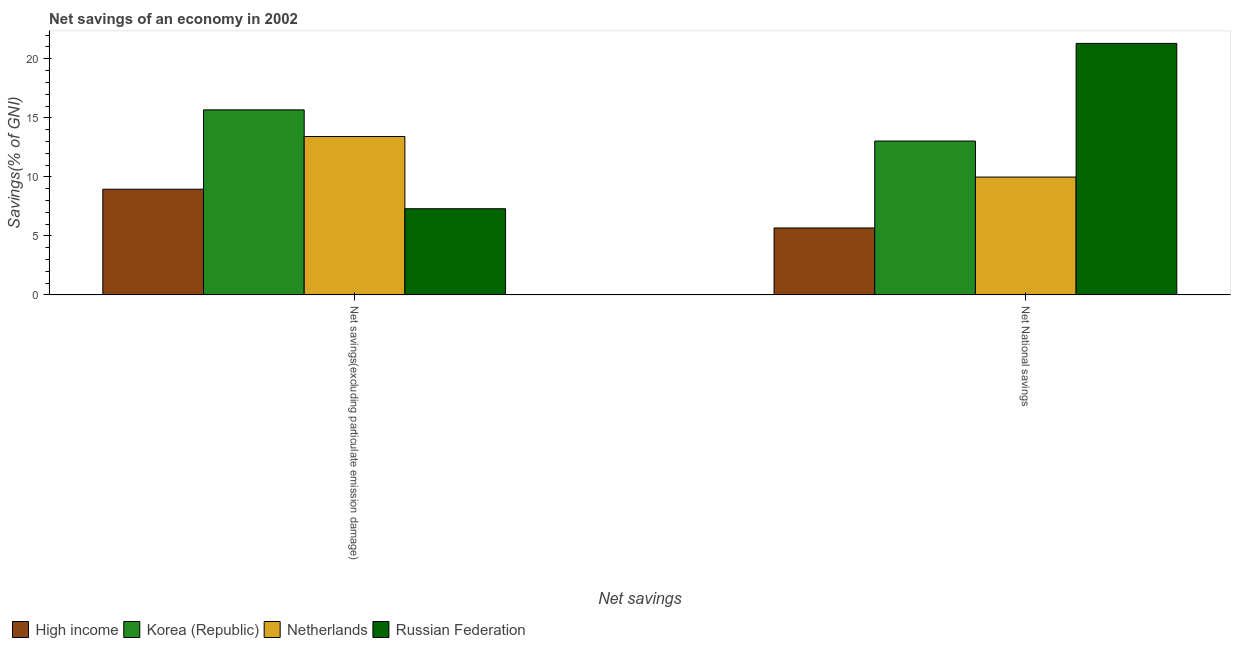How many different coloured bars are there?
Make the answer very short. 4. How many groups of bars are there?
Provide a succinct answer. 2. Are the number of bars per tick equal to the number of legend labels?
Keep it short and to the point. Yes. How many bars are there on the 1st tick from the right?
Provide a succinct answer. 4. What is the label of the 1st group of bars from the left?
Ensure brevity in your answer.  Net savings(excluding particulate emission damage). What is the net savings(excluding particulate emission damage) in High income?
Ensure brevity in your answer.  8.95. Across all countries, what is the maximum net national savings?
Provide a succinct answer. 21.31. Across all countries, what is the minimum net national savings?
Give a very brief answer. 5.67. In which country was the net national savings minimum?
Offer a very short reply. High income. What is the total net savings(excluding particulate emission damage) in the graph?
Give a very brief answer. 45.34. What is the difference between the net national savings in Netherlands and that in Korea (Republic)?
Ensure brevity in your answer.  -3.05. What is the difference between the net national savings in Russian Federation and the net savings(excluding particulate emission damage) in High income?
Offer a terse response. 12.35. What is the average net savings(excluding particulate emission damage) per country?
Provide a short and direct response. 11.34. What is the difference between the net savings(excluding particulate emission damage) and net national savings in Korea (Republic)?
Make the answer very short. 2.64. What is the ratio of the net national savings in Korea (Republic) to that in Netherlands?
Your answer should be compact. 1.31. Is the net national savings in Netherlands less than that in Russian Federation?
Your answer should be very brief. Yes. What does the 1st bar from the right in Net savings(excluding particulate emission damage) represents?
Your response must be concise. Russian Federation. Are all the bars in the graph horizontal?
Make the answer very short. No. Are the values on the major ticks of Y-axis written in scientific E-notation?
Offer a terse response. No. Does the graph contain grids?
Provide a succinct answer. No. How many legend labels are there?
Your answer should be very brief. 4. How are the legend labels stacked?
Your answer should be compact. Horizontal. What is the title of the graph?
Make the answer very short. Net savings of an economy in 2002. Does "Curacao" appear as one of the legend labels in the graph?
Keep it short and to the point. No. What is the label or title of the X-axis?
Offer a terse response. Net savings. What is the label or title of the Y-axis?
Offer a terse response. Savings(% of GNI). What is the Savings(% of GNI) of High income in Net savings(excluding particulate emission damage)?
Your answer should be compact. 8.95. What is the Savings(% of GNI) in Korea (Republic) in Net savings(excluding particulate emission damage)?
Provide a short and direct response. 15.67. What is the Savings(% of GNI) of Netherlands in Net savings(excluding particulate emission damage)?
Your answer should be compact. 13.42. What is the Savings(% of GNI) of Russian Federation in Net savings(excluding particulate emission damage)?
Make the answer very short. 7.3. What is the Savings(% of GNI) in High income in Net National savings?
Offer a terse response. 5.67. What is the Savings(% of GNI) in Korea (Republic) in Net National savings?
Offer a terse response. 13.03. What is the Savings(% of GNI) of Netherlands in Net National savings?
Your answer should be compact. 9.98. What is the Savings(% of GNI) of Russian Federation in Net National savings?
Provide a short and direct response. 21.31. Across all Net savings, what is the maximum Savings(% of GNI) of High income?
Your answer should be compact. 8.95. Across all Net savings, what is the maximum Savings(% of GNI) of Korea (Republic)?
Give a very brief answer. 15.67. Across all Net savings, what is the maximum Savings(% of GNI) of Netherlands?
Provide a short and direct response. 13.42. Across all Net savings, what is the maximum Savings(% of GNI) in Russian Federation?
Your response must be concise. 21.31. Across all Net savings, what is the minimum Savings(% of GNI) in High income?
Ensure brevity in your answer.  5.67. Across all Net savings, what is the minimum Savings(% of GNI) in Korea (Republic)?
Provide a short and direct response. 13.03. Across all Net savings, what is the minimum Savings(% of GNI) of Netherlands?
Your answer should be very brief. 9.98. Across all Net savings, what is the minimum Savings(% of GNI) in Russian Federation?
Your answer should be very brief. 7.3. What is the total Savings(% of GNI) in High income in the graph?
Ensure brevity in your answer.  14.62. What is the total Savings(% of GNI) of Korea (Republic) in the graph?
Make the answer very short. 28.71. What is the total Savings(% of GNI) of Netherlands in the graph?
Your answer should be very brief. 23.4. What is the total Savings(% of GNI) of Russian Federation in the graph?
Offer a terse response. 28.6. What is the difference between the Savings(% of GNI) in High income in Net savings(excluding particulate emission damage) and that in Net National savings?
Keep it short and to the point. 3.28. What is the difference between the Savings(% of GNI) of Korea (Republic) in Net savings(excluding particulate emission damage) and that in Net National savings?
Provide a succinct answer. 2.64. What is the difference between the Savings(% of GNI) in Netherlands in Net savings(excluding particulate emission damage) and that in Net National savings?
Provide a short and direct response. 3.44. What is the difference between the Savings(% of GNI) in Russian Federation in Net savings(excluding particulate emission damage) and that in Net National savings?
Your response must be concise. -14.01. What is the difference between the Savings(% of GNI) of High income in Net savings(excluding particulate emission damage) and the Savings(% of GNI) of Korea (Republic) in Net National savings?
Offer a terse response. -4.08. What is the difference between the Savings(% of GNI) in High income in Net savings(excluding particulate emission damage) and the Savings(% of GNI) in Netherlands in Net National savings?
Your response must be concise. -1.03. What is the difference between the Savings(% of GNI) of High income in Net savings(excluding particulate emission damage) and the Savings(% of GNI) of Russian Federation in Net National savings?
Ensure brevity in your answer.  -12.35. What is the difference between the Savings(% of GNI) in Korea (Republic) in Net savings(excluding particulate emission damage) and the Savings(% of GNI) in Netherlands in Net National savings?
Offer a terse response. 5.69. What is the difference between the Savings(% of GNI) in Korea (Republic) in Net savings(excluding particulate emission damage) and the Savings(% of GNI) in Russian Federation in Net National savings?
Your answer should be very brief. -5.63. What is the difference between the Savings(% of GNI) of Netherlands in Net savings(excluding particulate emission damage) and the Savings(% of GNI) of Russian Federation in Net National savings?
Your answer should be very brief. -7.89. What is the average Savings(% of GNI) in High income per Net savings?
Ensure brevity in your answer.  7.31. What is the average Savings(% of GNI) of Korea (Republic) per Net savings?
Your answer should be very brief. 14.35. What is the average Savings(% of GNI) of Netherlands per Net savings?
Provide a short and direct response. 11.7. What is the average Savings(% of GNI) in Russian Federation per Net savings?
Ensure brevity in your answer.  14.3. What is the difference between the Savings(% of GNI) of High income and Savings(% of GNI) of Korea (Republic) in Net savings(excluding particulate emission damage)?
Provide a short and direct response. -6.72. What is the difference between the Savings(% of GNI) in High income and Savings(% of GNI) in Netherlands in Net savings(excluding particulate emission damage)?
Your answer should be compact. -4.47. What is the difference between the Savings(% of GNI) of High income and Savings(% of GNI) of Russian Federation in Net savings(excluding particulate emission damage)?
Provide a succinct answer. 1.65. What is the difference between the Savings(% of GNI) of Korea (Republic) and Savings(% of GNI) of Netherlands in Net savings(excluding particulate emission damage)?
Ensure brevity in your answer.  2.26. What is the difference between the Savings(% of GNI) in Korea (Republic) and Savings(% of GNI) in Russian Federation in Net savings(excluding particulate emission damage)?
Keep it short and to the point. 8.38. What is the difference between the Savings(% of GNI) of Netherlands and Savings(% of GNI) of Russian Federation in Net savings(excluding particulate emission damage)?
Ensure brevity in your answer.  6.12. What is the difference between the Savings(% of GNI) in High income and Savings(% of GNI) in Korea (Republic) in Net National savings?
Provide a short and direct response. -7.36. What is the difference between the Savings(% of GNI) of High income and Savings(% of GNI) of Netherlands in Net National savings?
Your answer should be compact. -4.31. What is the difference between the Savings(% of GNI) in High income and Savings(% of GNI) in Russian Federation in Net National savings?
Your response must be concise. -15.64. What is the difference between the Savings(% of GNI) in Korea (Republic) and Savings(% of GNI) in Netherlands in Net National savings?
Offer a terse response. 3.05. What is the difference between the Savings(% of GNI) in Korea (Republic) and Savings(% of GNI) in Russian Federation in Net National savings?
Keep it short and to the point. -8.27. What is the difference between the Savings(% of GNI) of Netherlands and Savings(% of GNI) of Russian Federation in Net National savings?
Keep it short and to the point. -11.32. What is the ratio of the Savings(% of GNI) in High income in Net savings(excluding particulate emission damage) to that in Net National savings?
Make the answer very short. 1.58. What is the ratio of the Savings(% of GNI) of Korea (Republic) in Net savings(excluding particulate emission damage) to that in Net National savings?
Give a very brief answer. 1.2. What is the ratio of the Savings(% of GNI) in Netherlands in Net savings(excluding particulate emission damage) to that in Net National savings?
Provide a short and direct response. 1.34. What is the ratio of the Savings(% of GNI) in Russian Federation in Net savings(excluding particulate emission damage) to that in Net National savings?
Make the answer very short. 0.34. What is the difference between the highest and the second highest Savings(% of GNI) in High income?
Ensure brevity in your answer.  3.28. What is the difference between the highest and the second highest Savings(% of GNI) of Korea (Republic)?
Make the answer very short. 2.64. What is the difference between the highest and the second highest Savings(% of GNI) in Netherlands?
Your answer should be compact. 3.44. What is the difference between the highest and the second highest Savings(% of GNI) of Russian Federation?
Offer a very short reply. 14.01. What is the difference between the highest and the lowest Savings(% of GNI) in High income?
Offer a terse response. 3.28. What is the difference between the highest and the lowest Savings(% of GNI) in Korea (Republic)?
Keep it short and to the point. 2.64. What is the difference between the highest and the lowest Savings(% of GNI) in Netherlands?
Provide a short and direct response. 3.44. What is the difference between the highest and the lowest Savings(% of GNI) of Russian Federation?
Offer a terse response. 14.01. 